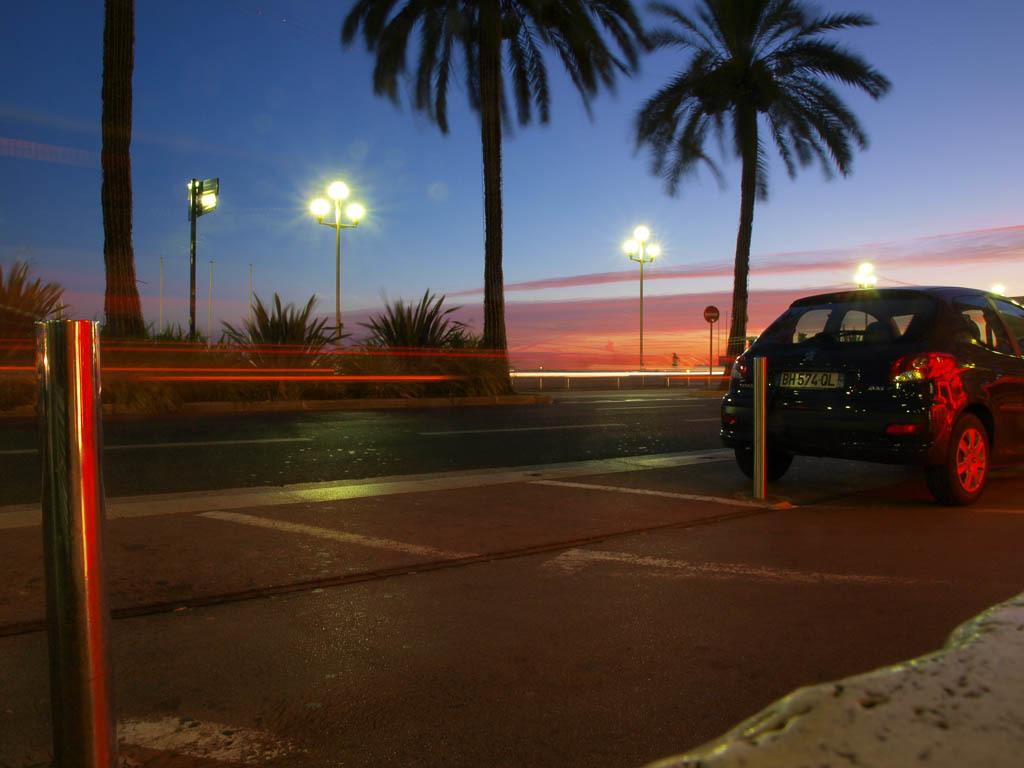What is the main subject of the image? There is a car on the road in the image. What can be seen in the background of the image? There are trees and street lights in the background of the image. What is visible in the sky in the image? The sky is visible in the image, and clouds are present. How many bikes are performing magic tricks in the image? There are no bikes or magic tricks present in the image. 